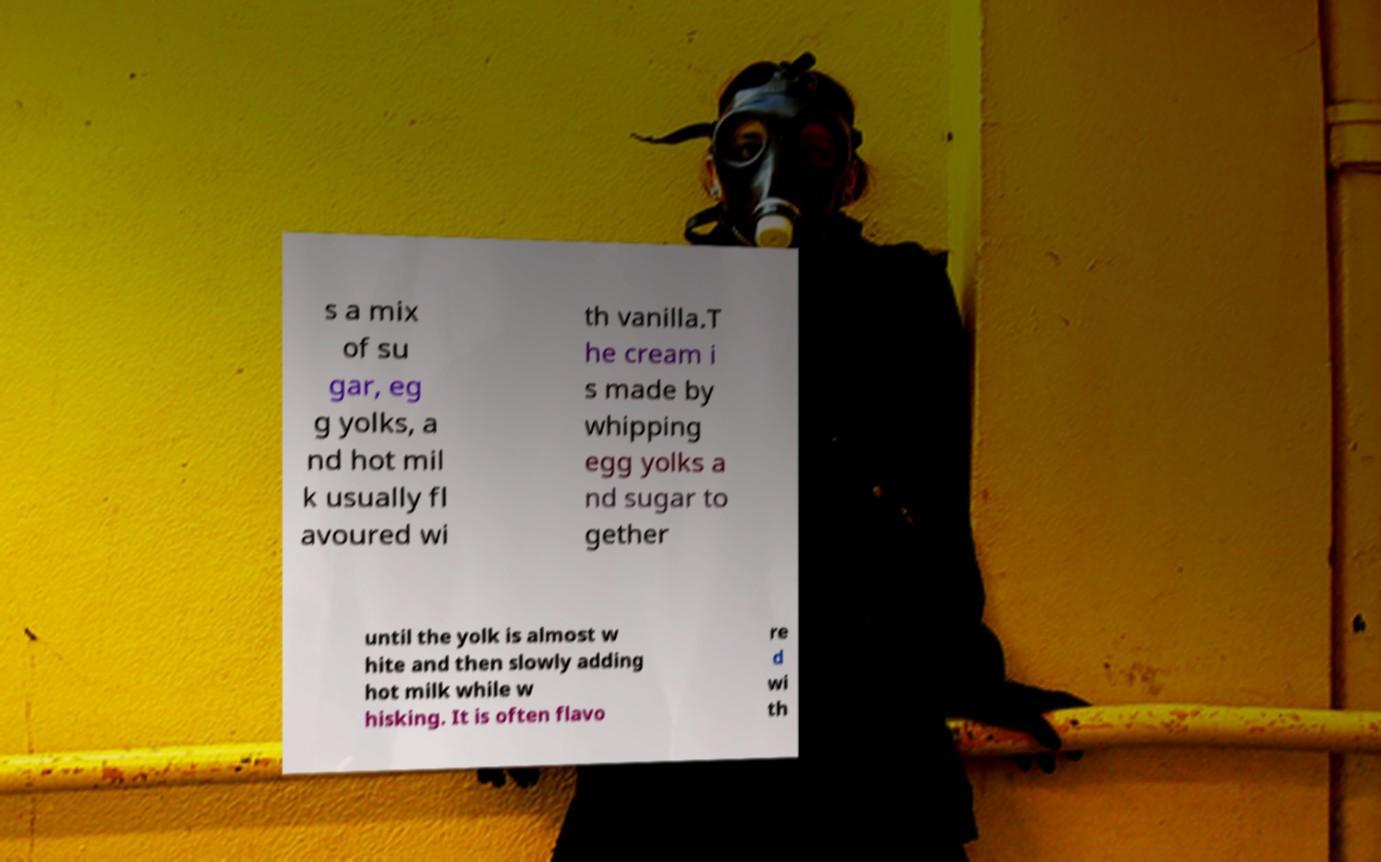What messages or text are displayed in this image? I need them in a readable, typed format. s a mix of su gar, eg g yolks, a nd hot mil k usually fl avoured wi th vanilla.T he cream i s made by whipping egg yolks a nd sugar to gether until the yolk is almost w hite and then slowly adding hot milk while w hisking. It is often flavo re d wi th 